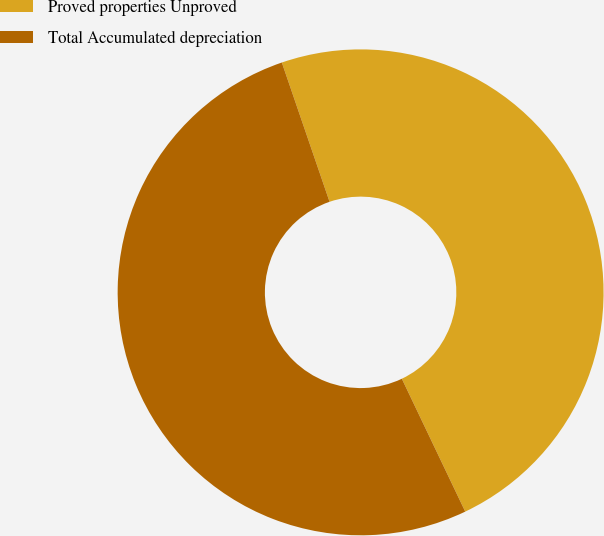<chart> <loc_0><loc_0><loc_500><loc_500><pie_chart><fcel>Proved properties Unproved<fcel>Total Accumulated depreciation<nl><fcel>48.17%<fcel>51.83%<nl></chart> 